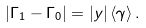<formula> <loc_0><loc_0><loc_500><loc_500>\left | \Gamma _ { 1 } - \Gamma _ { 0 } \right | = | y | \, \langle \gamma \rangle \, .</formula> 